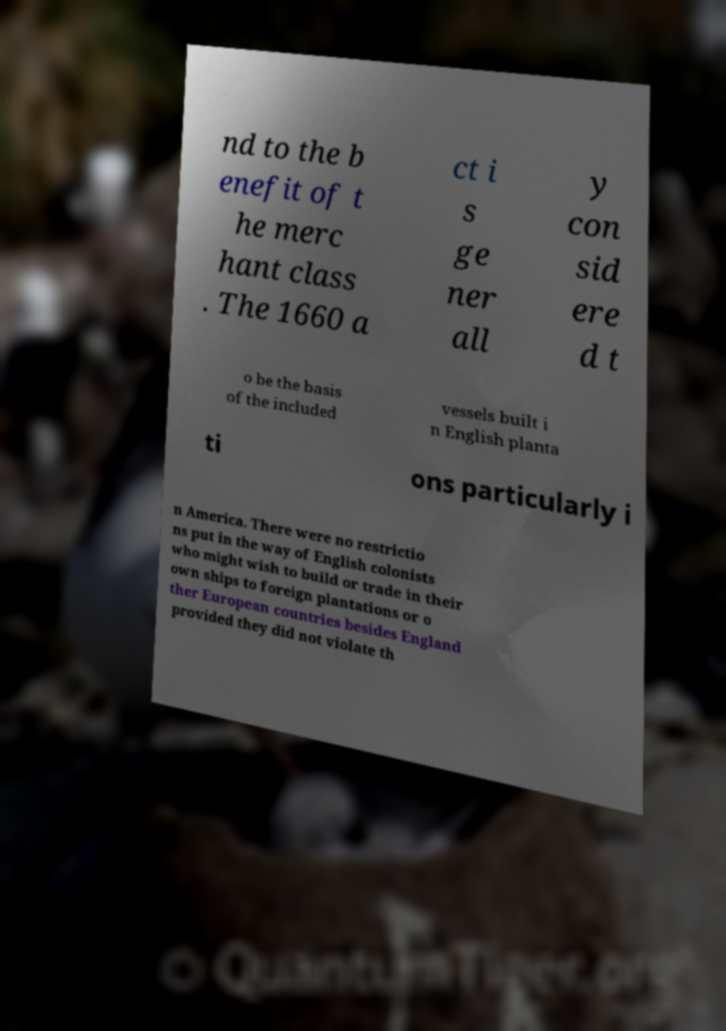Please identify and transcribe the text found in this image. nd to the b enefit of t he merc hant class . The 1660 a ct i s ge ner all y con sid ere d t o be the basis of the included vessels built i n English planta ti ons particularly i n America. There were no restrictio ns put in the way of English colonists who might wish to build or trade in their own ships to foreign plantations or o ther European countries besides England provided they did not violate th 